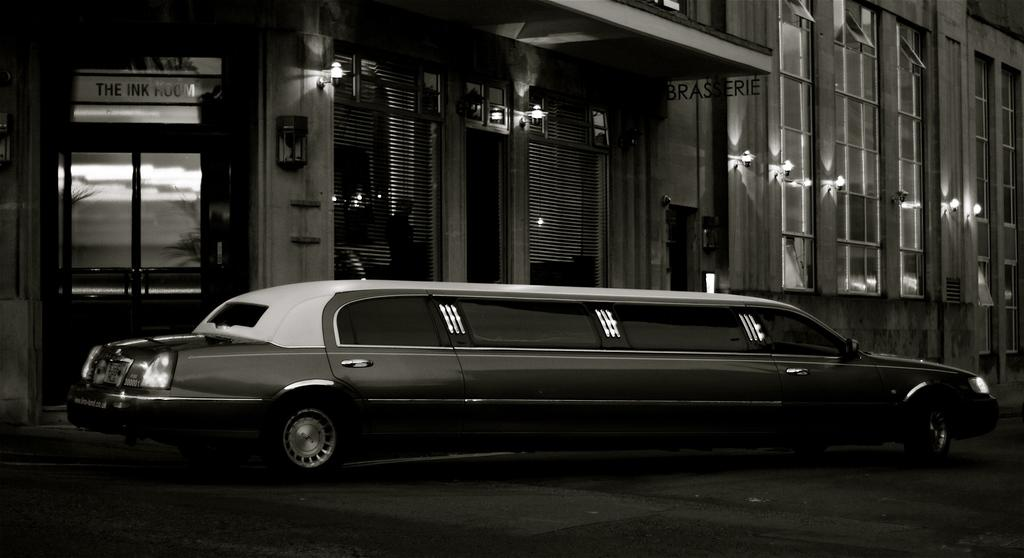What is the main subject of the image? The main subject of the image is a car on the road. What else can be seen in the image besides the car? There is a building and lights beside the car and building in the image. Where is the kitty hiding in the image? There is no kitty present in the image. What type of bait is being used to catch fish in the image? There is no fishing or bait present in the image. 